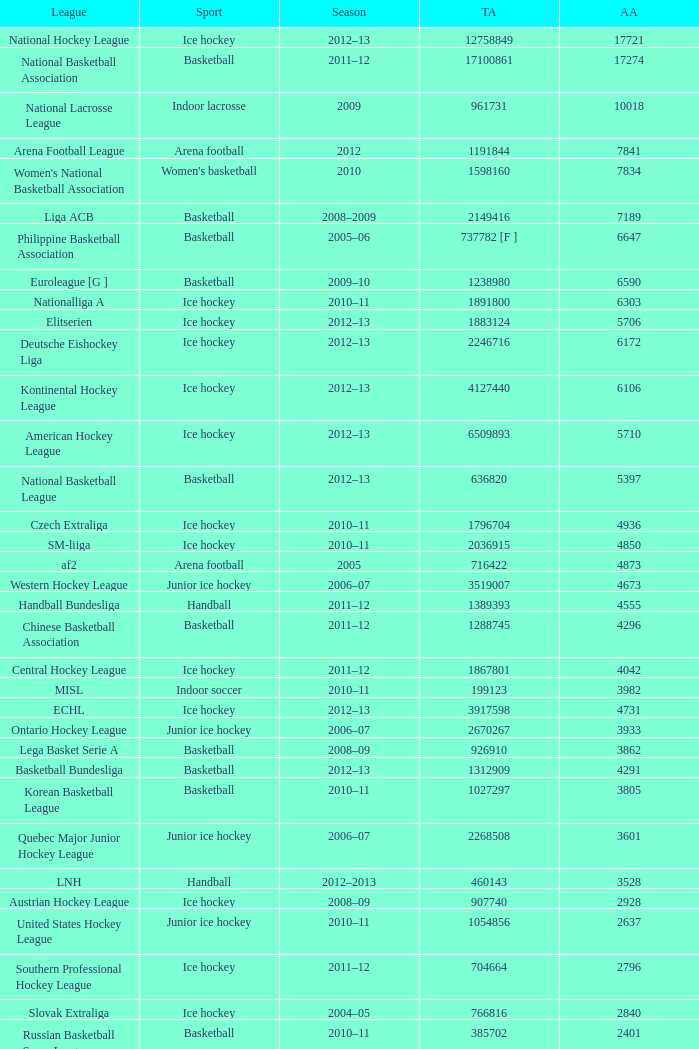What was the highest average attendance in the 2009 season? 10018.0. 